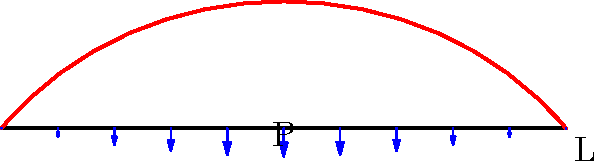A bridge inspired by the shape of a Les Paul guitar's body is designed with a deck length of $L$ meters. The load distribution on the deck follows a sinusoidal pattern, represented by the function $P(x) = P_{max} \sin(\frac{\pi x}{L})$, where $P_{max}$ is the maximum load intensity. If the total load on the bridge is equal to $\frac{2}{\pi}P_{max}L$, what is the reaction force at each support? Let's approach this step-by-step, channeling the spirit of one-hit wonders who briefly shone bright:

1) The load distribution is given by $P(x) = P_{max} \sin(\frac{\pi x}{L})$

2) To find the total load, we integrate this function over the length of the bridge:

   $\int_0^L P(x) dx = \int_0^L P_{max} \sin(\frac{\pi x}{L}) dx$

3) We're told that this integral equals $\frac{2}{\pi}P_{max}L$

4) For a simply supported bridge, the reaction forces at each end will be equal due to symmetry. Let's call this force R.

5) The sum of these reaction forces must equal the total load:

   $2R = \frac{2}{\pi}P_{max}L$

6) Solving for R:

   $R = \frac{1}{\pi}P_{max}L$

This result is reminiscent of how quickly some pop stars rise and fall - the reaction force is a simple fraction of the product of the maximum load intensity and the bridge length.
Answer: $R = \frac{1}{\pi}P_{max}L$ 